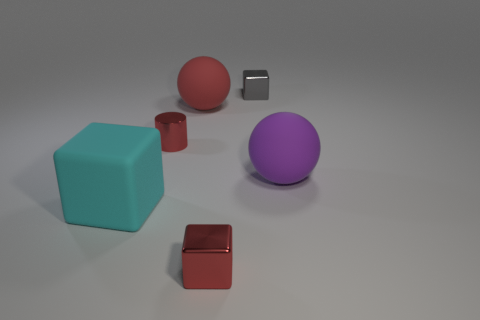Subtract all cyan cubes. How many cubes are left? 2 Add 3 small red cubes. How many objects exist? 9 Subtract all red blocks. How many blocks are left? 2 Subtract 2 balls. How many balls are left? 0 Subtract all cylinders. How many objects are left? 5 Add 3 small matte cylinders. How many small matte cylinders exist? 3 Subtract 0 blue balls. How many objects are left? 6 Subtract all blue blocks. Subtract all gray spheres. How many blocks are left? 3 Subtract all large red matte things. Subtract all small green objects. How many objects are left? 5 Add 6 small gray blocks. How many small gray blocks are left? 7 